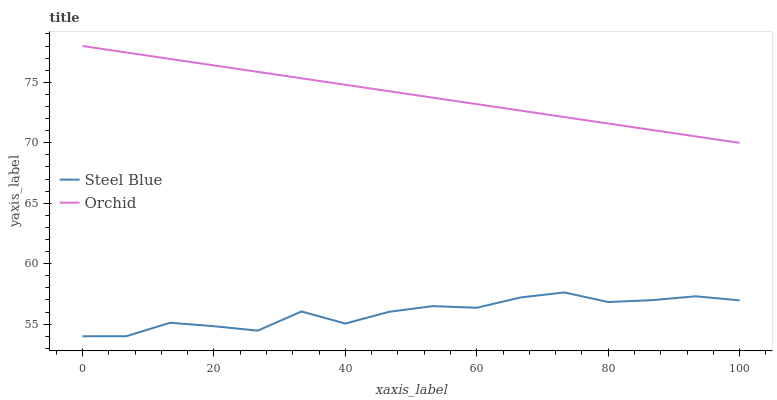Does Steel Blue have the minimum area under the curve?
Answer yes or no. Yes. Does Orchid have the maximum area under the curve?
Answer yes or no. Yes. Does Orchid have the minimum area under the curve?
Answer yes or no. No. Is Orchid the smoothest?
Answer yes or no. Yes. Is Steel Blue the roughest?
Answer yes or no. Yes. Is Orchid the roughest?
Answer yes or no. No. Does Steel Blue have the lowest value?
Answer yes or no. Yes. Does Orchid have the lowest value?
Answer yes or no. No. Does Orchid have the highest value?
Answer yes or no. Yes. Is Steel Blue less than Orchid?
Answer yes or no. Yes. Is Orchid greater than Steel Blue?
Answer yes or no. Yes. Does Steel Blue intersect Orchid?
Answer yes or no. No. 